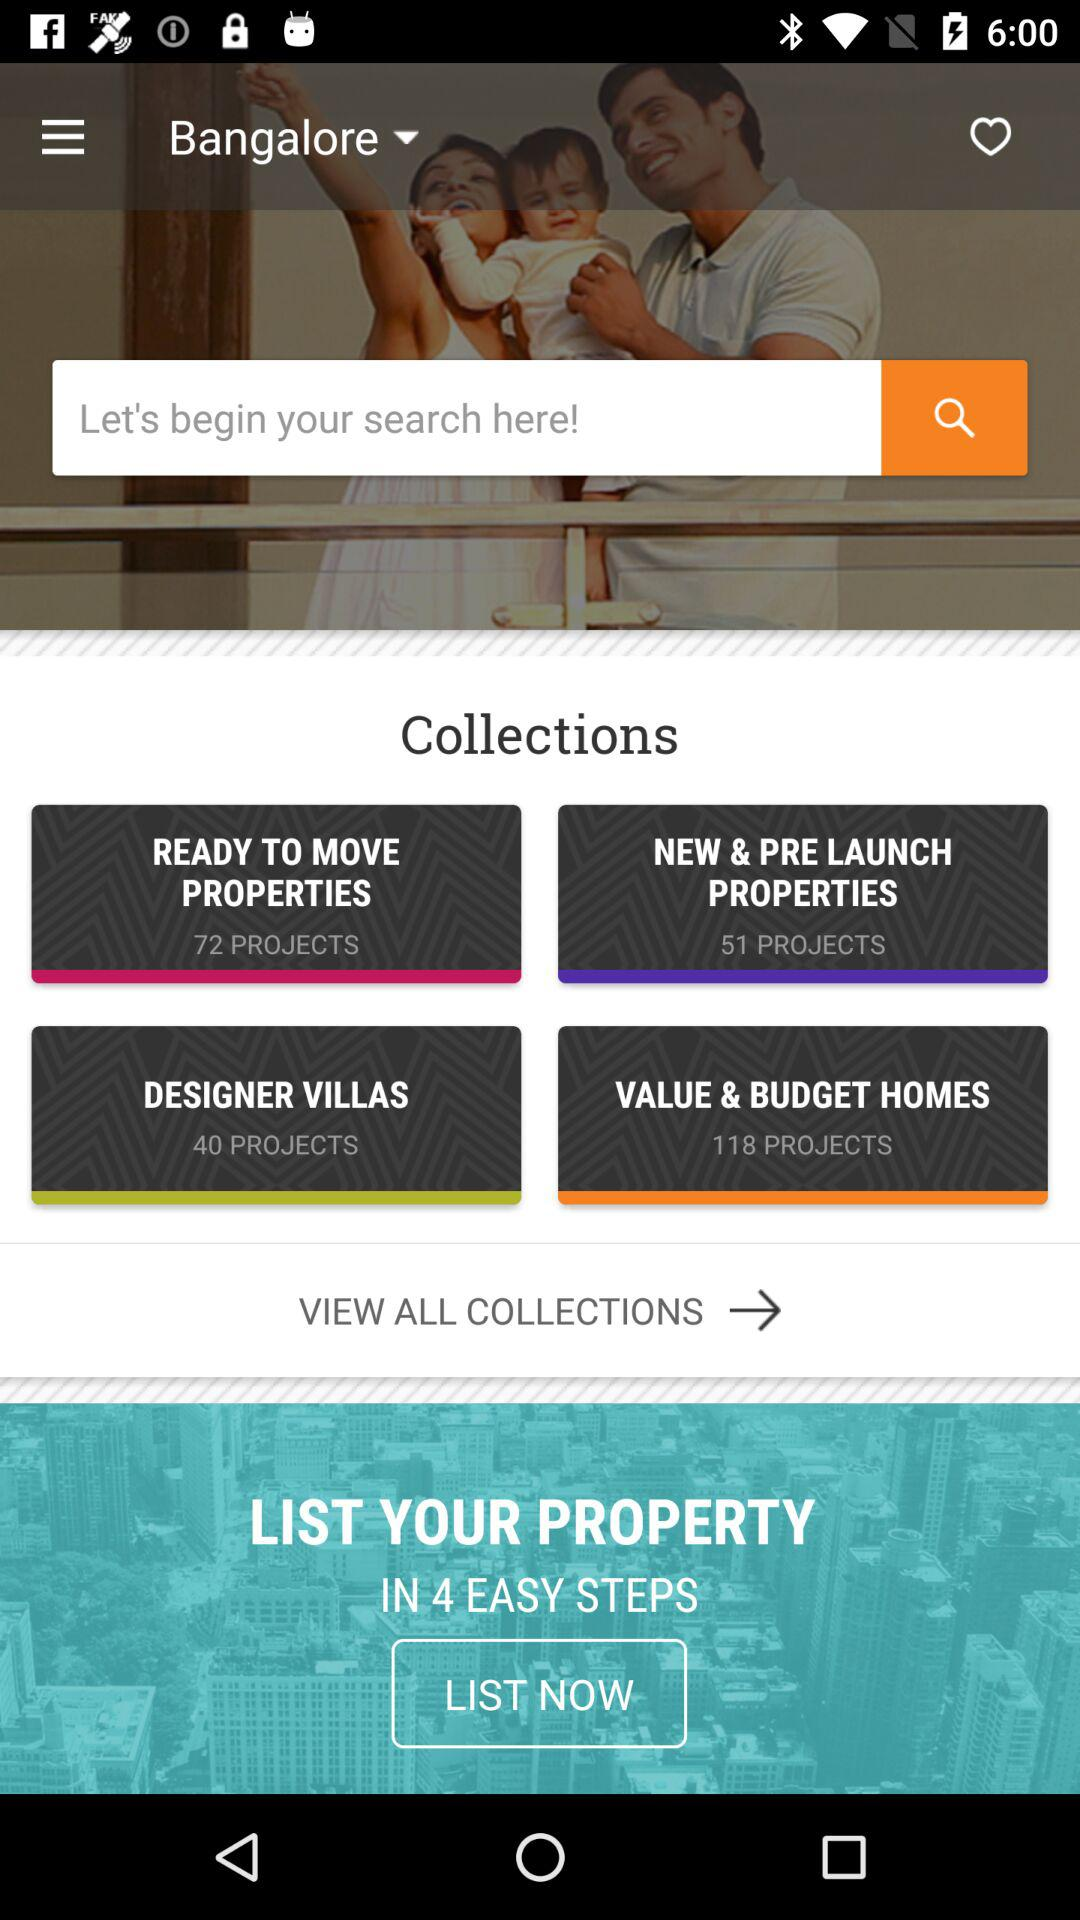How many designer villas are there? There are 40 designer villas. 